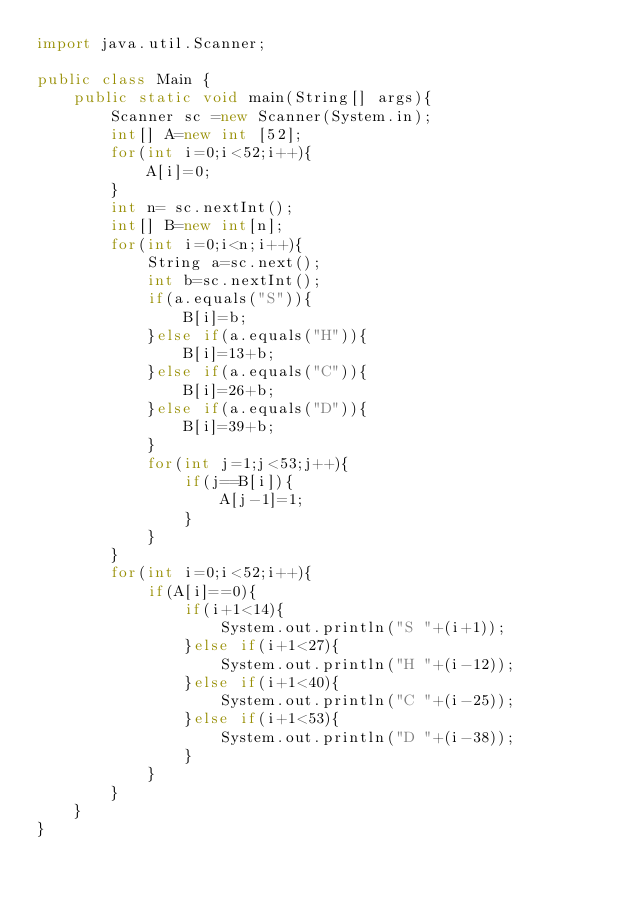Convert code to text. <code><loc_0><loc_0><loc_500><loc_500><_Java_>import java.util.Scanner;

public class Main {
	public static void main(String[] args){
		Scanner sc =new Scanner(System.in);
		int[] A=new int [52];
	   	for(int i=0;i<52;i++){
	   		A[i]=0;
	   	}
	   	int n= sc.nextInt();
    	int[] B=new int[n];
    	for(int i=0;i<n;i++){
    		String a=sc.next();
	    	int b=sc.nextInt();
	   		if(a.equals("S")){
	   			B[i]=b;
	   		}else if(a.equals("H")){
	   			B[i]=13+b;
    		}else if(a.equals("C")){
    			B[i]=26+b;
	    	}else if(a.equals("D")){
	    		B[i]=39+b;
	   		}
	   		for(int j=1;j<53;j++){
	   			if(j==B[i]){
	   				A[j-1]=1;
	   			}
	   		}
	   	}
    	for(int i=0;i<52;i++){
    		if(A[i]==0){
    			if(i+1<14){
    				System.out.println("S "+(i+1));
    			}else if(i+1<27){
    				System.out.println("H "+(i-12));
    			}else if(i+1<40){
    				System.out.println("C "+(i-25));
    			}else if(i+1<53){
    				System.out.println("D "+(i-38));
    			}
    		}
    	}
	}
}</code> 